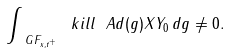<formula> <loc_0><loc_0><loc_500><loc_500>\int _ { \ G F _ { x , t ^ { + } } } \ k i l l { \ A d ( g ) X } { Y _ { 0 } } \, d g \ne 0 .</formula> 